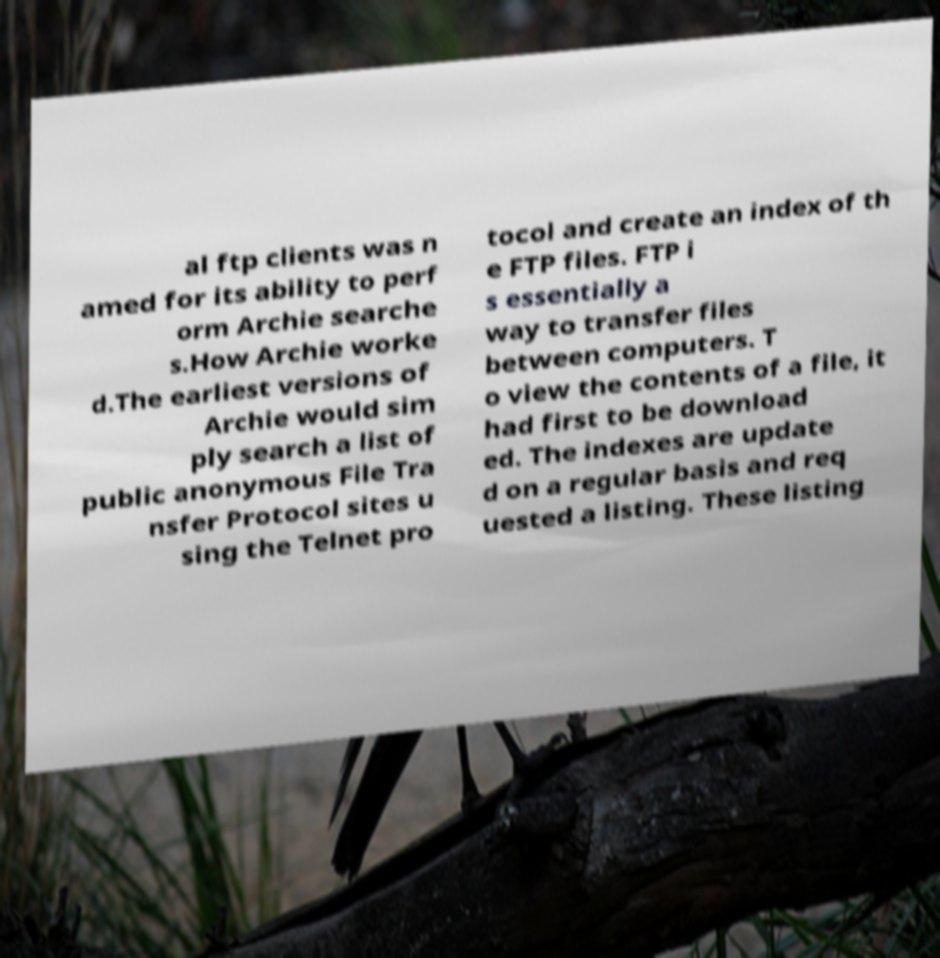For documentation purposes, I need the text within this image transcribed. Could you provide that? al ftp clients was n amed for its ability to perf orm Archie searche s.How Archie worke d.The earliest versions of Archie would sim ply search a list of public anonymous File Tra nsfer Protocol sites u sing the Telnet pro tocol and create an index of th e FTP files. FTP i s essentially a way to transfer files between computers. T o view the contents of a file, it had first to be download ed. The indexes are update d on a regular basis and req uested a listing. These listing 